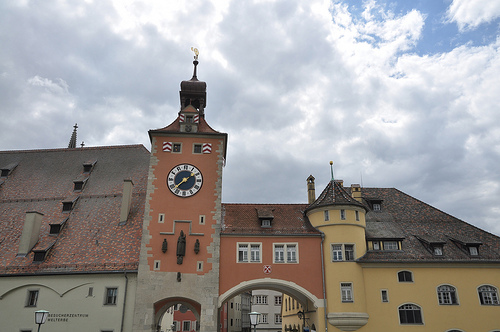Please provide a short description for this region: [0.72, 0.32, 0.86, 0.48]. This part of the image shows a cloud floating in the sky. 